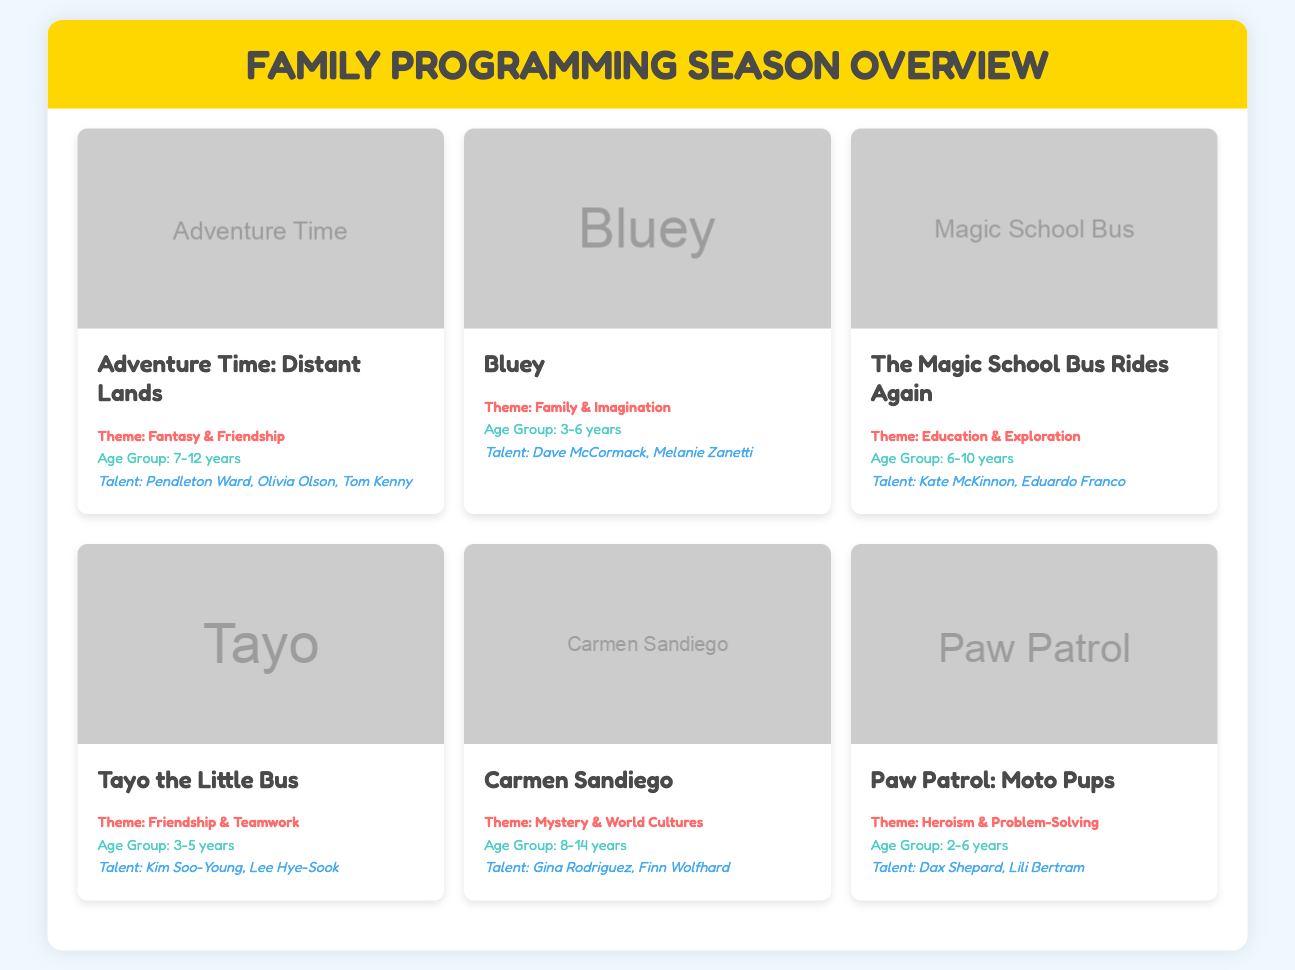What is the title of the first show listed? The title of the first show listed is found at the top of the first show card.
Answer: Adventure Time: Distant Lands What age group is targeted by the show "Bluey"? The targeted age group is mentioned in the show card for "Bluey".
Answer: 3-6 years Who is one of the talents involved in "The Magic School Bus Rides Again"? The talent involved is found in the show card for "The Magic School Bus Rides Again".
Answer: Kate McKinnon What theme does "Carmen Sandiego" focus on? The theme of "Carmen Sandiego" is specified in its show card.
Answer: Mystery & World Cultures How many shows are featured in the menu? The total number of shows can be counted based on the number of show cards visible in the document.
Answer: 6 Which show has a theme centered on friendship and teamwork? The theme centered on friendship and teamwork is specified in the show card for that particular show.
Answer: Tayo the Little Bus What is the theme of "Paw Patrol: Moto Pups"? The theme is detailed in the show information under "Paw Patrol: Moto Pups".
Answer: Heroism & Problem-Solving Which talent is associated with "Bluey"? The associated talent is listed in the show information for "Bluey".
Answer: Dave McCormack 